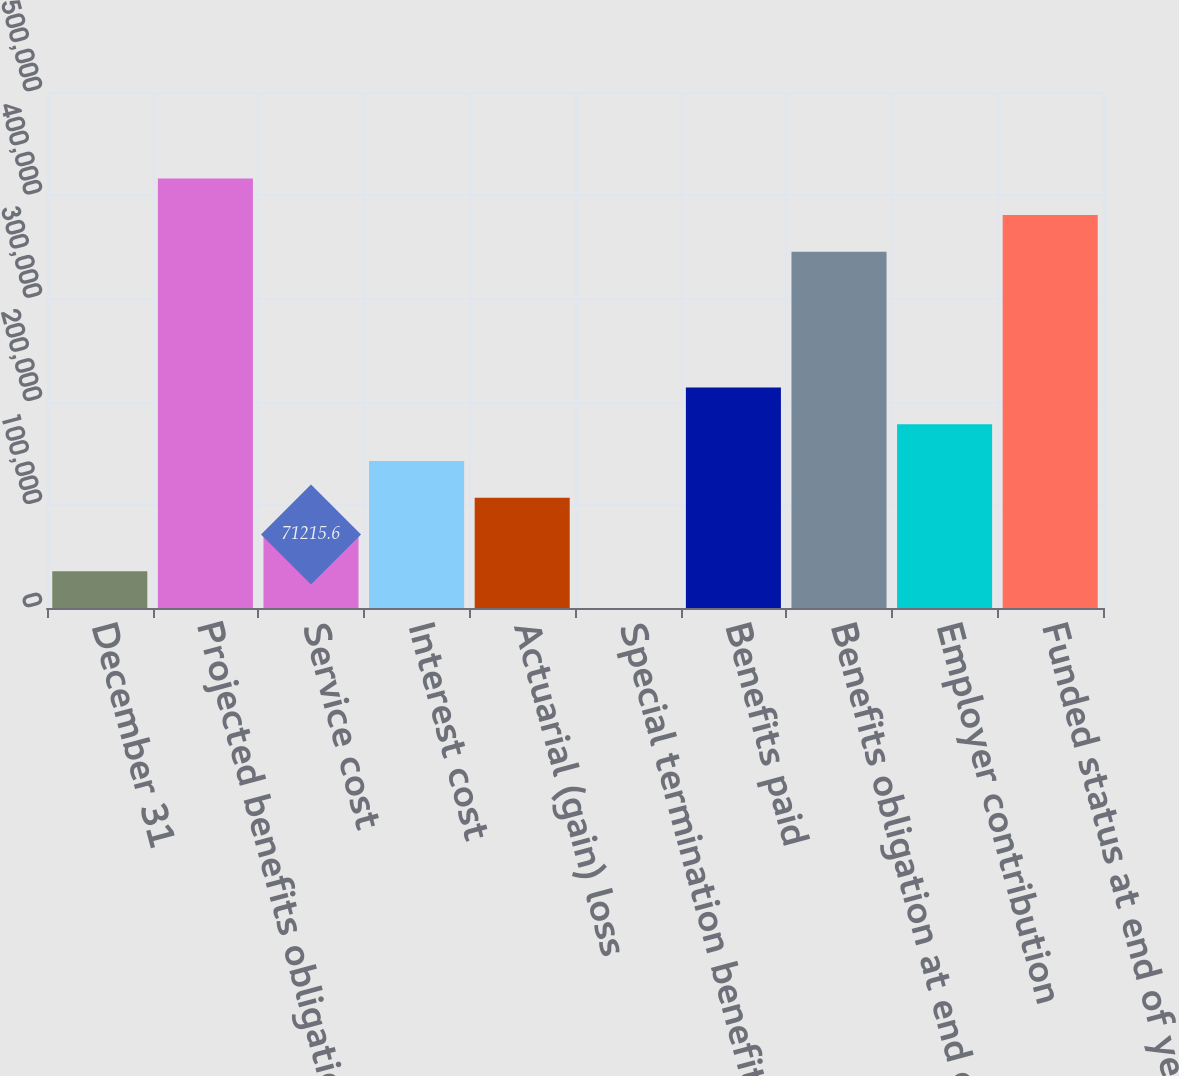<chart> <loc_0><loc_0><loc_500><loc_500><bar_chart><fcel>December 31<fcel>Projected benefits obligation<fcel>Service cost<fcel>Interest cost<fcel>Actuarial (gain) loss<fcel>Special termination benefits<fcel>Benefits paid<fcel>Benefits obligation at end of<fcel>Employer contribution<fcel>Funded status at end of year<nl><fcel>35632.8<fcel>416282<fcel>71215.6<fcel>142381<fcel>106798<fcel>50<fcel>213547<fcel>345116<fcel>177964<fcel>380699<nl></chart> 